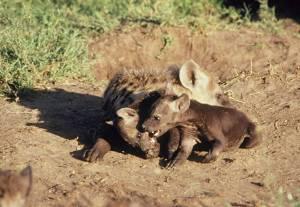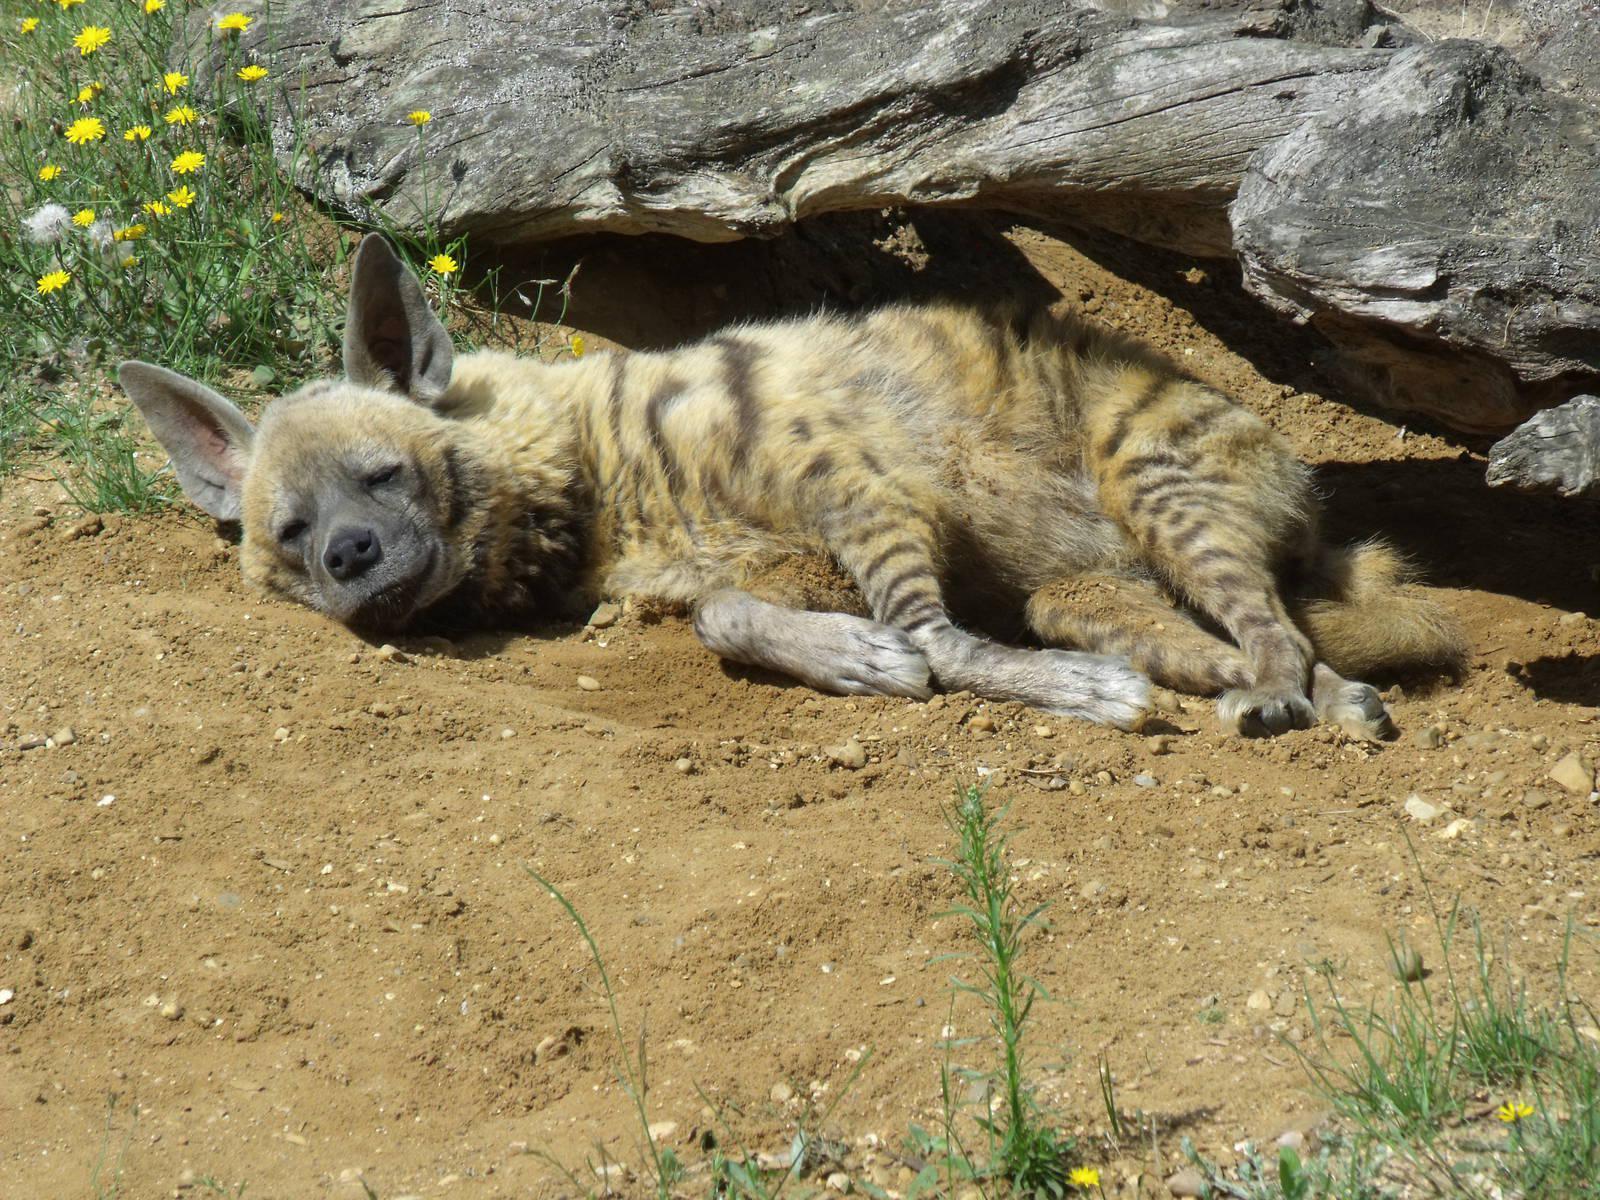The first image is the image on the left, the second image is the image on the right. Assess this claim about the two images: "One hyena is lying on the ground with a baby near it in the image on the right.". Correct or not? Answer yes or no. No. 